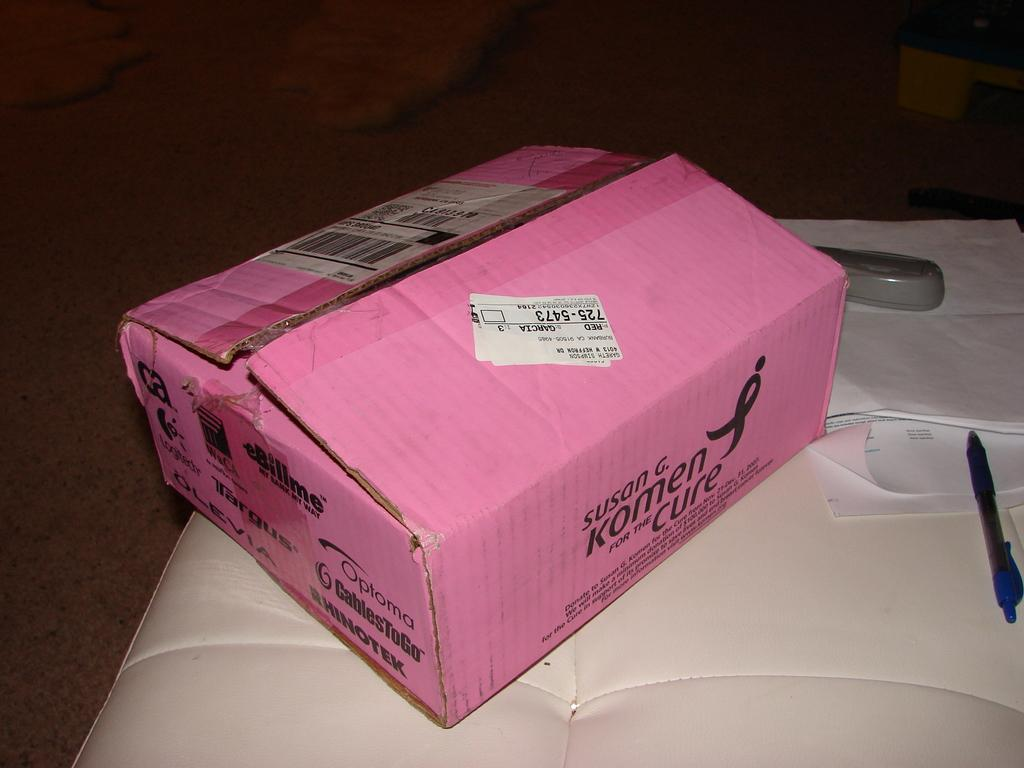<image>
Summarize the visual content of the image. A pink box has a sticker with 725-5473 on the label. 